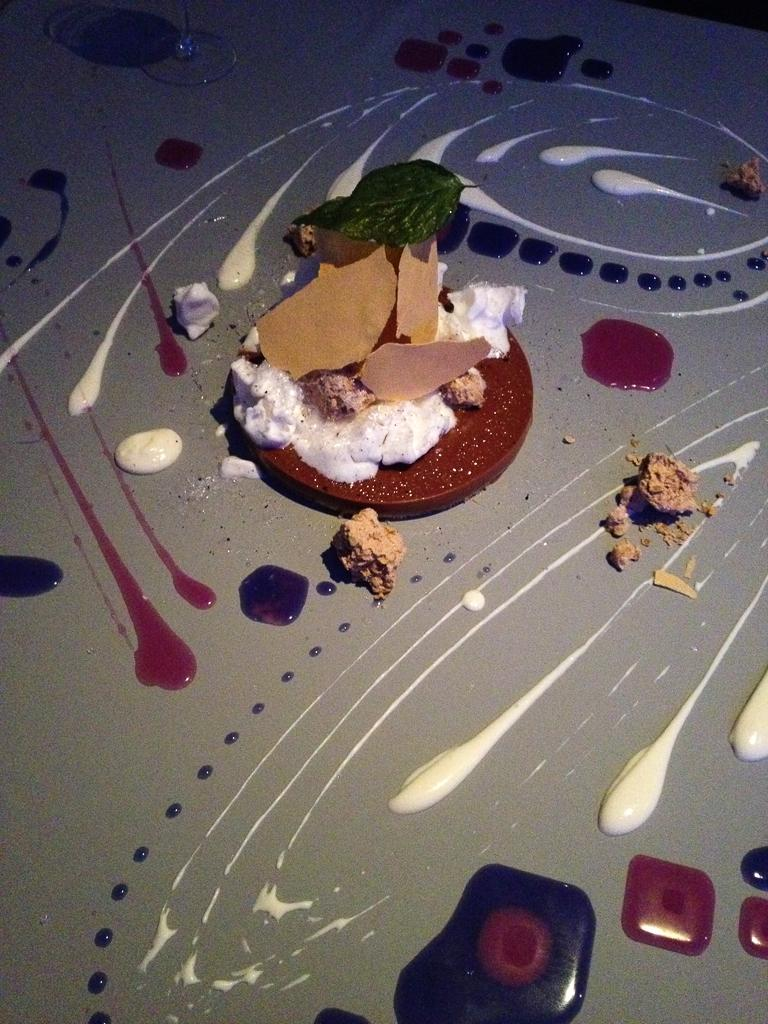What is the main structure in the center of the image? There is a platform in the center of the image. What is placed on the platform? A plate, a glass object, a leaf, and food items are present on the platform. Can you describe the glass object on the platform? Unfortunately, the facts provided do not give a detailed description of the glass object. What type of food items can be seen on the platform? The facts provided do not specify the type of food items on the platform. How many crows are standing on the feet of the government official in the image? There are no crows or government officials present in the image. 